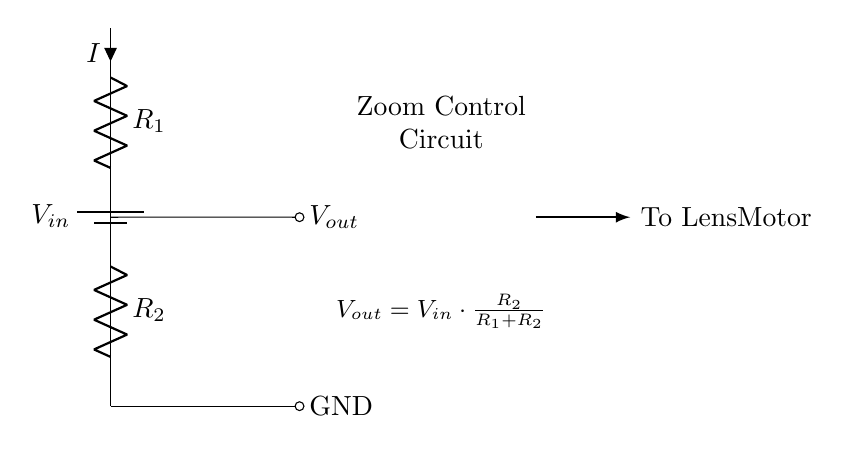What is the input voltage for this circuit? The input voltage is represented as V in the circuit diagram. It is the voltage supplied from the battery at the top of the circuit.
Answer: V in What are the resistance values in the circuit? The circuit shows two resistors, labeled R1 and R2. The values of these resistors are not specified, but they are necessary components for the voltage divider to function properly.
Answer: R1, R2 What is the output voltage formula for this circuit? The output voltage is given by the formula V out = V in multiplied by R2 divided by the sum of R1 and R2. This relationship indicates how the output voltage is derived from the input voltage based on the resistance values.
Answer: V out = V in * (R2 / (R1 + R2)) What happens to the output voltage if R1 increases? If R1 increases, the output voltage V out will decrease according to the voltage divider formula, because the larger resistance will take a greater share of the total voltage drop.
Answer: Decreases What does the output voltage control in this circuit? The output voltage in this circuit is used to control the motor of the camera lens, indicating that it adjusts the zoom mechanism. This connection is represented by the line leading to the lens motor in the diagram.
Answer: Lens motor What is the effect of decreasing R2 on output voltage? Decreasing R2 would result in a reduction of output voltage V out, as the output voltage is directly proportional to R2. This change affects how much voltage is available to drive the lens motor.
Answer: Decreases 